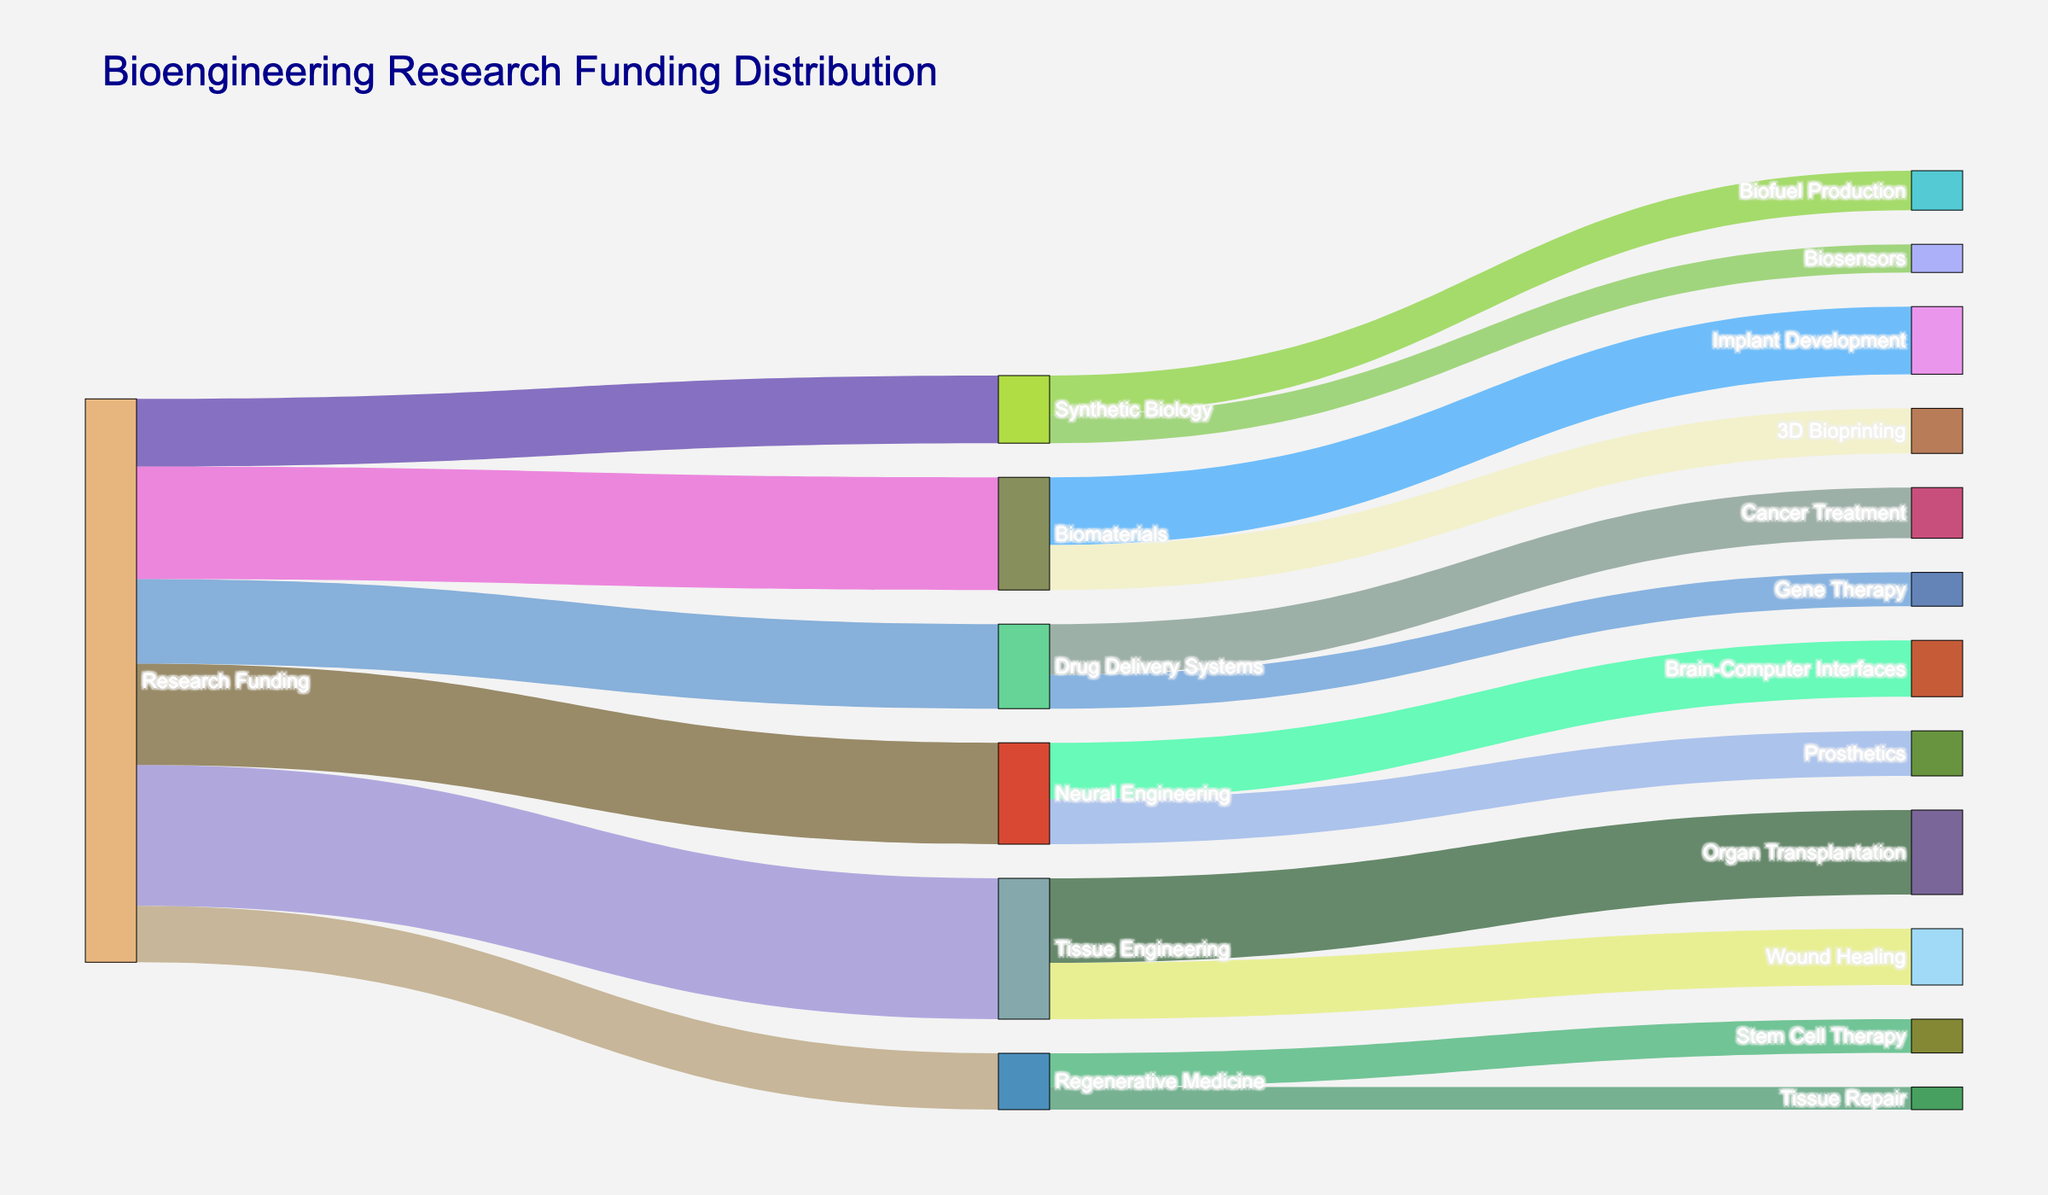What is the title of the figure? The title of the figure is located at the top and is clearly written in a larger font compared to the rest of the diagram.
Answer: Bioengineering Research Funding Distribution How much funding is allocated to Drug Delivery Systems? Drug Delivery Systems is a target node directly linked from Research Funding, and the value on the link shows the amount allocated.
Answer: 15 Which subfield receives the highest amount of research funding? By examining the width of the links emanating from Research Funding and reading their values, it is clear that Tissue Engineering receives the highest funding.
Answer: Tissue Engineering What is the total amount of funding allocated to applications within Biomaterials? Biomaterials is linked to two applications: Implant Development (12) and 3D Bioprinting (8). Sum these values to find the total.
Answer: 20 How much more funding does Tissue Engineering receive compared to Synthetic Biology? Compare the values of funding directed to Tissue Engineering (25) and Synthetic Biology (12). Subtract the smaller value from the larger one.
Answer: 13 Which application within Neural Engineering receives more funding, Brain-Computer Interfaces or Prosthetics? Compare the values associated with Brain-Computer Interfaces (10) and Prosthetics (8). Brain-Computer Interfaces has a higher value.
Answer: Brain-Computer Interfaces What percentage of the total research funding is allocated to Tissue Engineering? Sum all the values of the funding directed from Research Funding to calculate the total (25 + 20 + 18 + 15 + 12 + 10 = 100). Then, divide the amount for Tissue Engineering (25) by the total and multiply by 100 to get the percentage (25/100*100).
Answer: 25% What is the difference in funding between Cancer Treatment and Gene Therapy within Drug Delivery Systems? Look at the values linked from Drug Delivery Systems to Cancer Treatment (9) and Gene Therapy (6), then subtract the smaller from the larger.
Answer: 3 Which application receives funding from multiple subfields? Identify nodes that have links coming from more than one subfield. Here, Tissue Repair receives funding from Regenerative Medicine only, so no application receives funding from multiple subfields.
Answer: None 